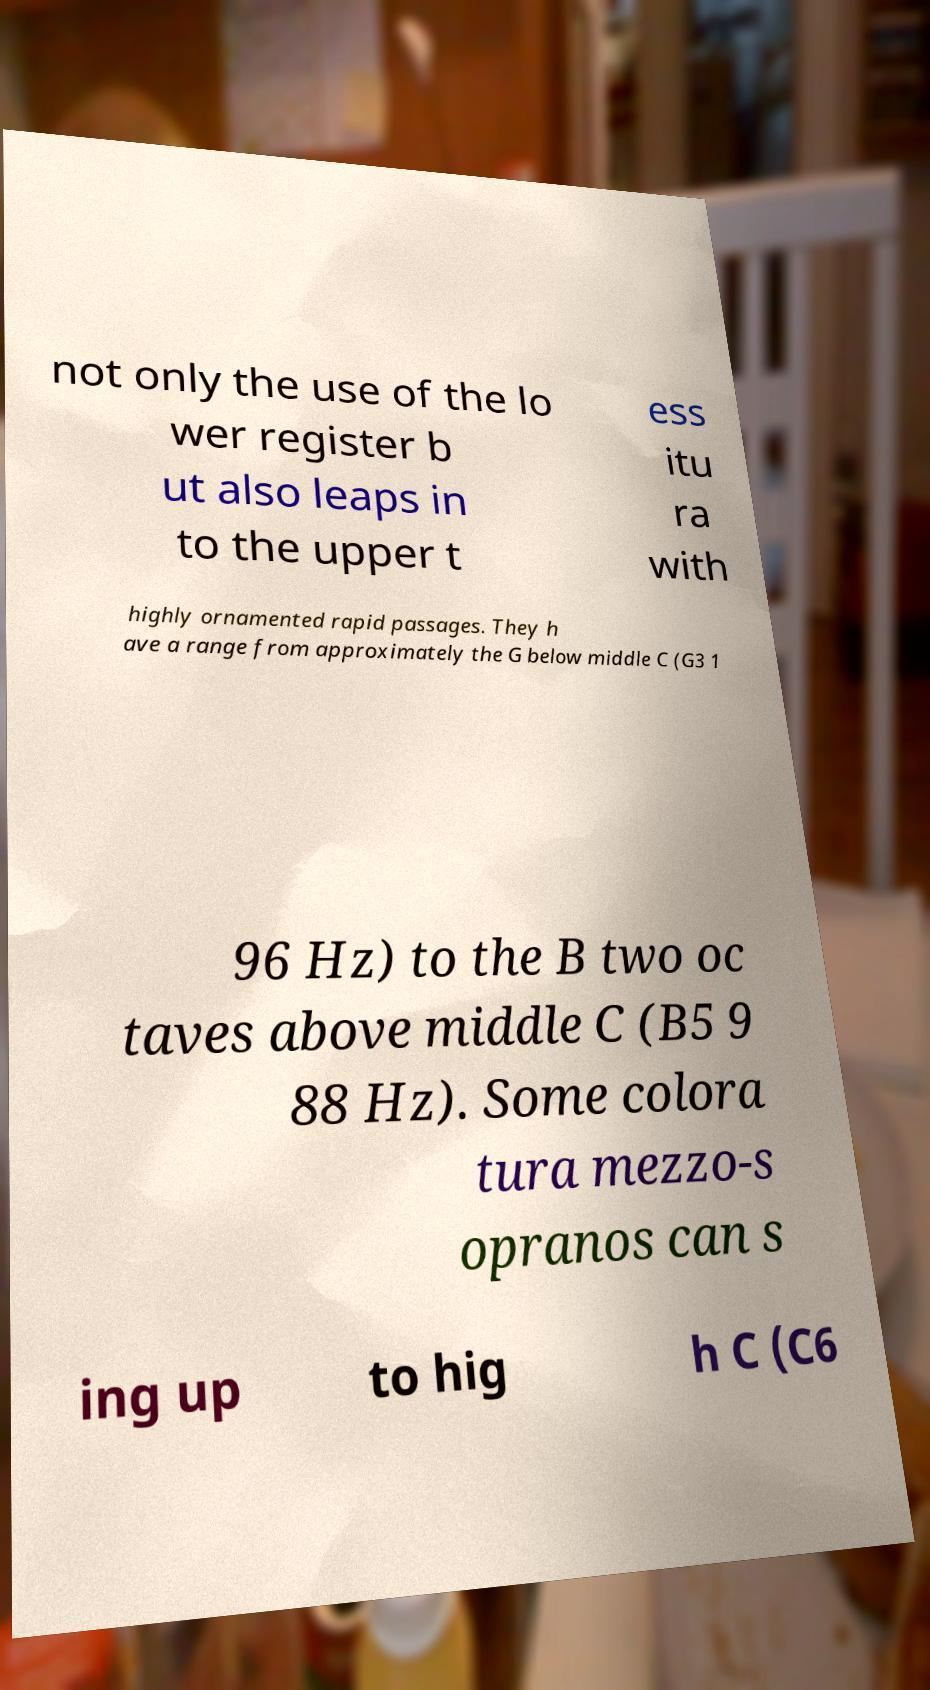Please read and relay the text visible in this image. What does it say? not only the use of the lo wer register b ut also leaps in to the upper t ess itu ra with highly ornamented rapid passages. They h ave a range from approximately the G below middle C (G3 1 96 Hz) to the B two oc taves above middle C (B5 9 88 Hz). Some colora tura mezzo-s opranos can s ing up to hig h C (C6 